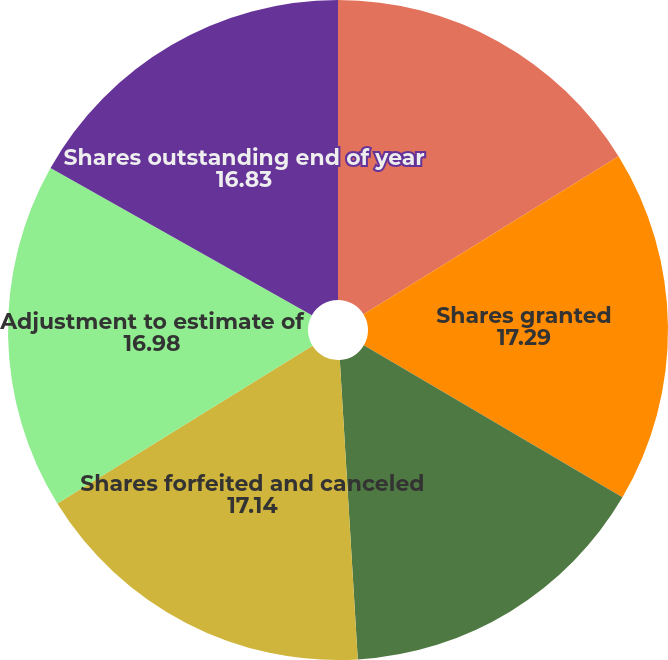<chart> <loc_0><loc_0><loc_500><loc_500><pie_chart><fcel>Shares outstanding beginning<fcel>Shares granted<fcel>Shares vested<fcel>Shares forfeited and canceled<fcel>Adjustment to estimate of<fcel>Shares outstanding end of year<nl><fcel>16.17%<fcel>17.29%<fcel>15.58%<fcel>17.14%<fcel>16.98%<fcel>16.83%<nl></chart> 